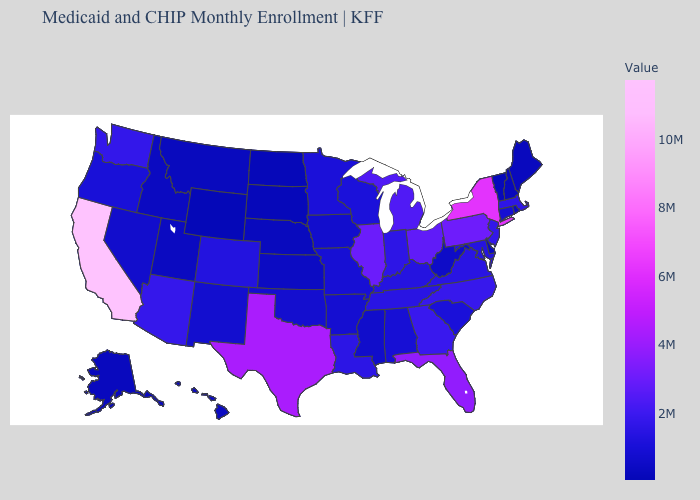Which states have the highest value in the USA?
Quick response, please. California. Which states have the highest value in the USA?
Concise answer only. California. Does Minnesota have the lowest value in the USA?
Answer briefly. No. Is the legend a continuous bar?
Give a very brief answer. Yes. Among the states that border New York , which have the highest value?
Quick response, please. Pennsylvania. Which states have the lowest value in the Northeast?
Concise answer only. Vermont. 